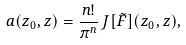<formula> <loc_0><loc_0><loc_500><loc_500>a ( z _ { 0 } , z ) = \frac { n ! } { \pi ^ { n } } \, J [ \tilde { F } ] ( z _ { 0 } , z ) ,</formula> 